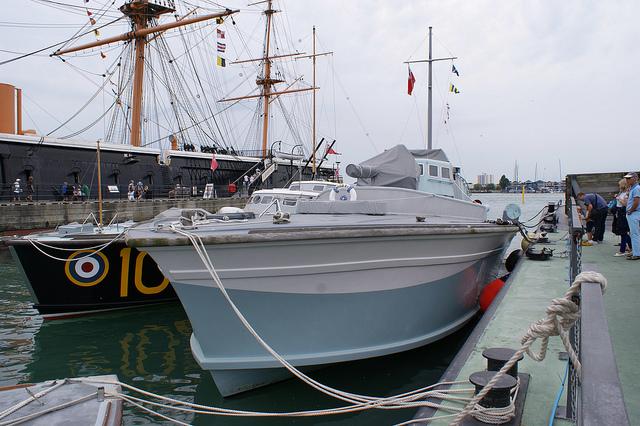Why are all these boats parked here?
Short answer required. Dock. What color is the water?
Short answer required. Blue. Is the water calm?
Give a very brief answer. Yes. How many boats are parked?
Short answer required. 2. 